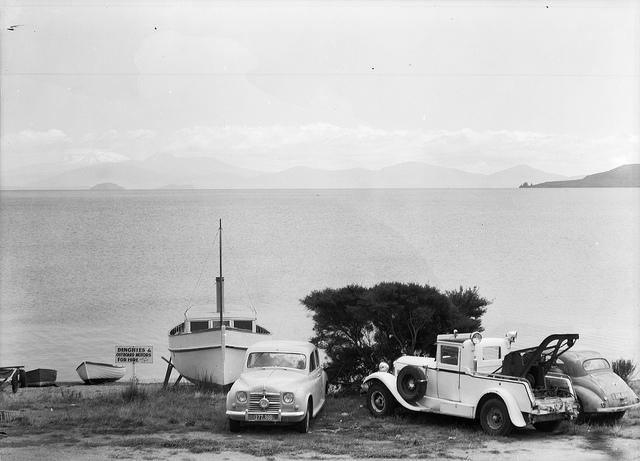Are motorcycles visible?
Quick response, please. No. What color is the four door car?
Give a very brief answer. White. Is there a stranded boat in the picture?
Give a very brief answer. Yes. Is there a car in the picture?
Quick response, please. Yes. Is this an old photo?
Be succinct. Yes. Why is there an umbrella on top of this truck in the foreground?
Be succinct. No umbrella. How many cars are shown?
Give a very brief answer. 3. Are these cars still sold today?
Quick response, please. No. How many people is in the truck?
Concise answer only. 0. Is this a family picture taken long ago?
Keep it brief. Yes. What is the brown substance on the ground?
Answer briefly. Dirt. 